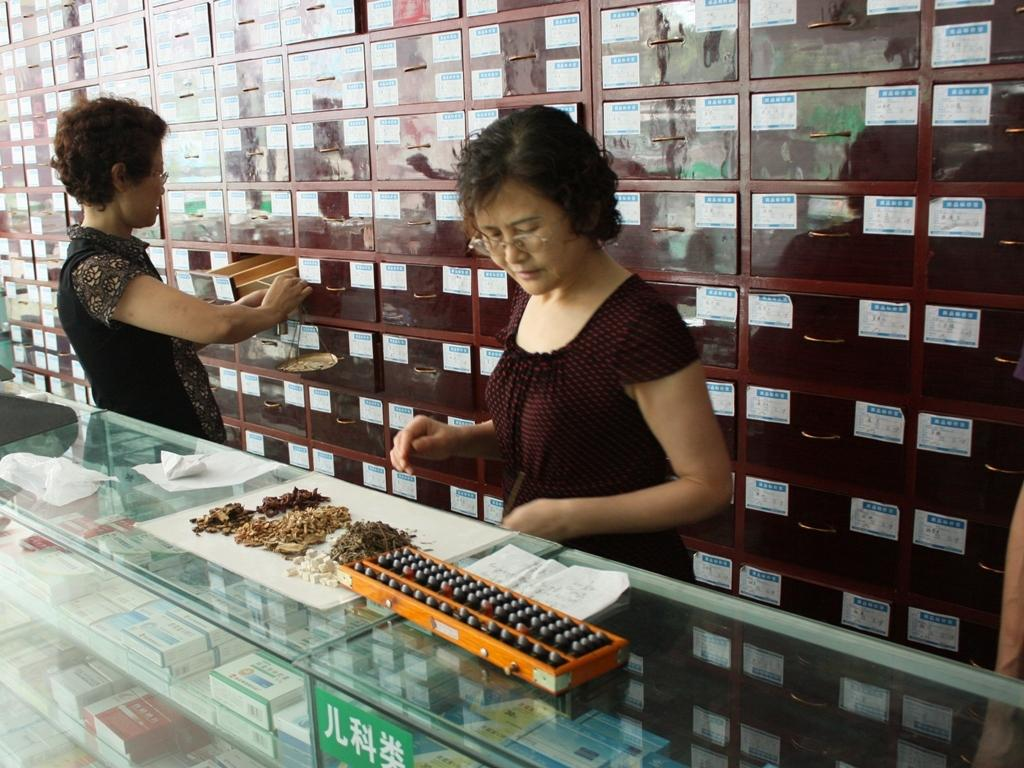How many people are in the image? There are two persons standing in the image. What can be seen behind the persons? There is a group of racks visible behind the persons. What is in the front of the image? There are objects on a glass surface in the front of the image. What type of pan is being used by the police in the image? There is no pan or police present in the image. 